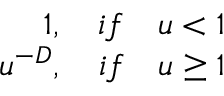Convert formula to latex. <formula><loc_0><loc_0><loc_500><loc_500>\begin{array} { r } { 1 , \quad i f \quad u < 1 } \\ { u ^ { - D } , \quad i f \quad u \geq 1 } \end{array}</formula> 